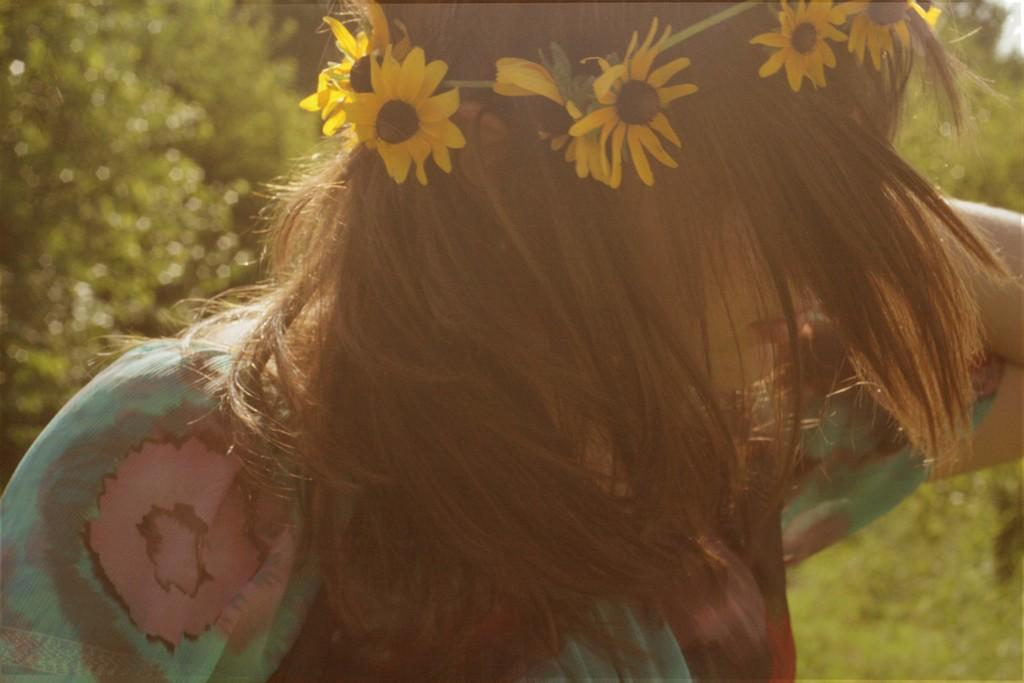Who is the main subject in the image? There is a woman in the image. What is the woman wearing on her head? The woman is wearing a tiara. What color is the tiara? The tiara is green. Can you describe the background of the image? The background of the image is blurred. What type of brain can be seen in the image? There is no brain present in the image; it features a woman wearing a green tiara. What star is visible in the image? There is no star visible in the image. 